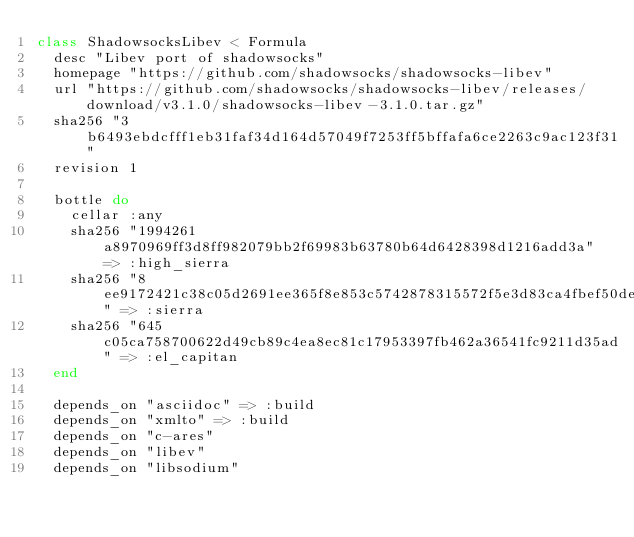<code> <loc_0><loc_0><loc_500><loc_500><_Ruby_>class ShadowsocksLibev < Formula
  desc "Libev port of shadowsocks"
  homepage "https://github.com/shadowsocks/shadowsocks-libev"
  url "https://github.com/shadowsocks/shadowsocks-libev/releases/download/v3.1.0/shadowsocks-libev-3.1.0.tar.gz"
  sha256 "3b6493ebdcfff1eb31faf34d164d57049f7253ff5bffafa6ce2263c9ac123f31"
  revision 1

  bottle do
    cellar :any
    sha256 "1994261a8970969ff3d8ff982079bb2f69983b63780b64d6428398d1216add3a" => :high_sierra
    sha256 "8ee9172421c38c05d2691ee365f8e853c5742878315572f5e3d83ca4fbef50de" => :sierra
    sha256 "645c05ca758700622d49cb89c4ea8ec81c17953397fb462a36541fc9211d35ad" => :el_capitan
  end

  depends_on "asciidoc" => :build
  depends_on "xmlto" => :build
  depends_on "c-ares"
  depends_on "libev"
  depends_on "libsodium"</code> 